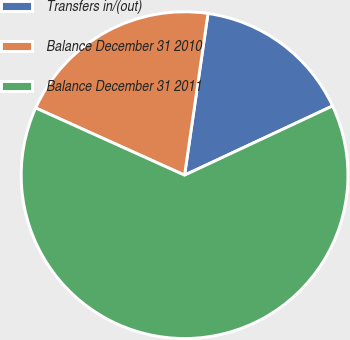Convert chart. <chart><loc_0><loc_0><loc_500><loc_500><pie_chart><fcel>Transfers in/(out)<fcel>Balance December 31 2010<fcel>Balance December 31 2011<nl><fcel>15.75%<fcel>20.54%<fcel>63.71%<nl></chart> 